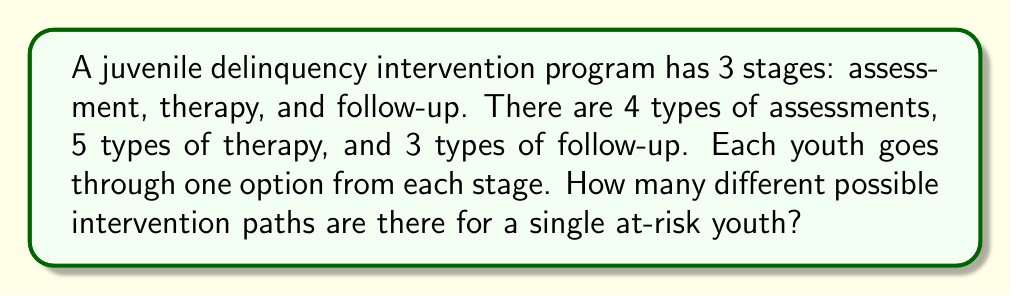Provide a solution to this math problem. To solve this problem, we'll use the multiplication principle of counting. This principle states that if we have a sequence of choices, and the number of options for each choice is independent of the other choices, then the total number of possible outcomes is the product of the number of options for each choice.

Let's break it down step-by-step:

1) For the assessment stage, there are 4 options.
2) For the therapy stage, there are 5 options.
3) For the follow-up stage, there are 3 options.

Each youth must go through one option from each stage, and the choice in one stage doesn't affect the choices available in the other stages.

Therefore, we can calculate the total number of possible intervention paths as:

$$ \text{Total paths} = \text{Assessment options} \times \text{Therapy options} \times \text{Follow-up options} $$

$$ \text{Total paths} = 4 \times 5 \times 3 = 60 $$

This means there are 60 different possible intervention paths for a single at-risk youth in this program.
Answer: 60 